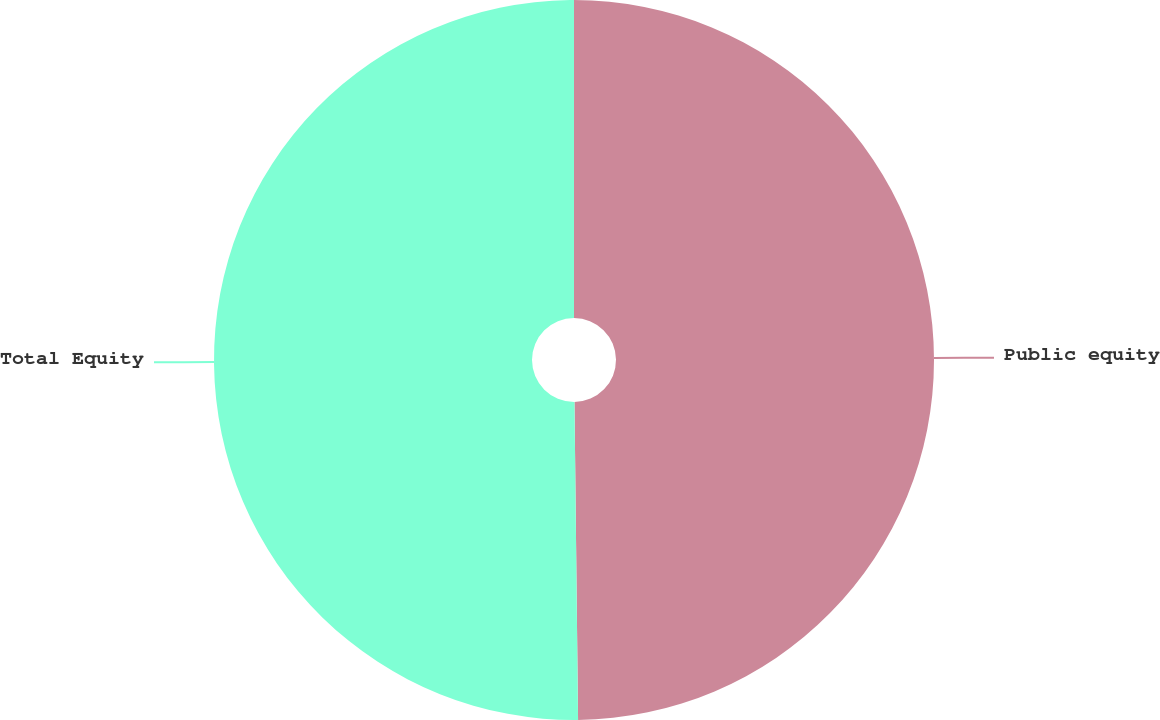Convert chart. <chart><loc_0><loc_0><loc_500><loc_500><pie_chart><fcel>Public equity<fcel>Total Equity<nl><fcel>49.82%<fcel>50.18%<nl></chart> 